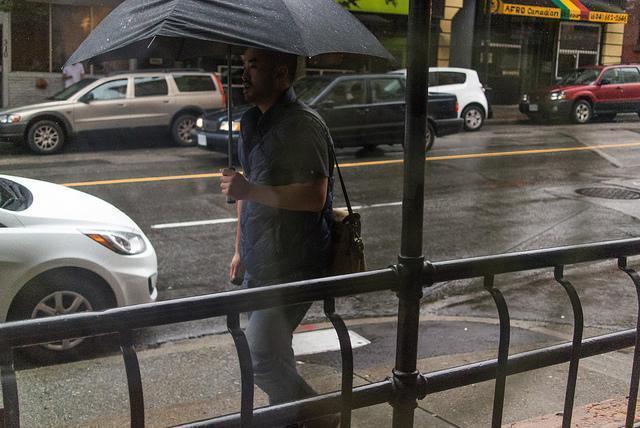From what does the man with the umbrella protect himself?
Select the accurate response from the four choices given to answer the question.
Options: Rain, snow, sun glare, gunfire. Rain. 